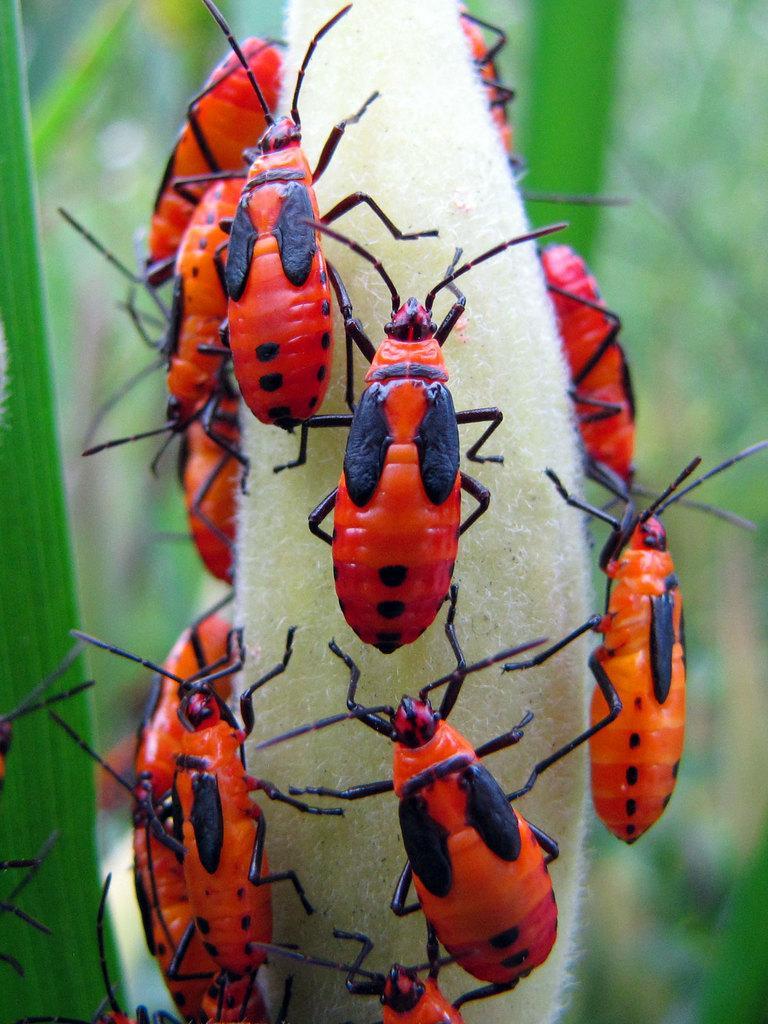In one or two sentences, can you explain what this image depicts? In the image we can see there are many insects, orange, red and black in color. These are the leaves and the background is blurred. 